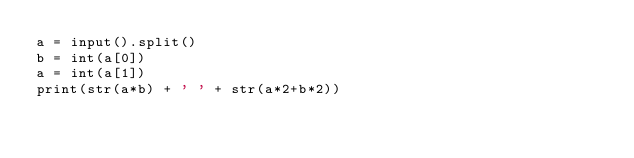<code> <loc_0><loc_0><loc_500><loc_500><_Python_>a = input().split()
b = int(a[0])
a = int(a[1])
print(str(a*b) + ' ' + str(a*2+b*2))
</code> 